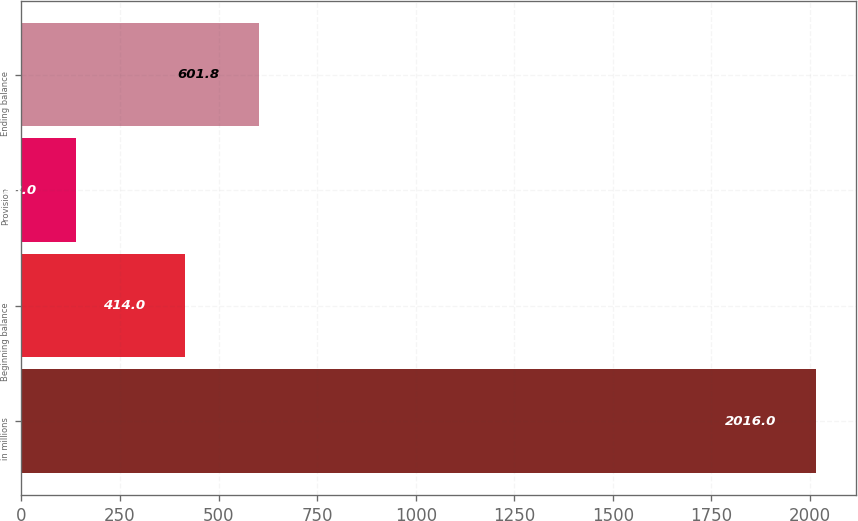Convert chart. <chart><loc_0><loc_0><loc_500><loc_500><bar_chart><fcel>in millions<fcel>Beginning balance<fcel>Provision<fcel>Ending balance<nl><fcel>2016<fcel>414<fcel>138<fcel>601.8<nl></chart> 